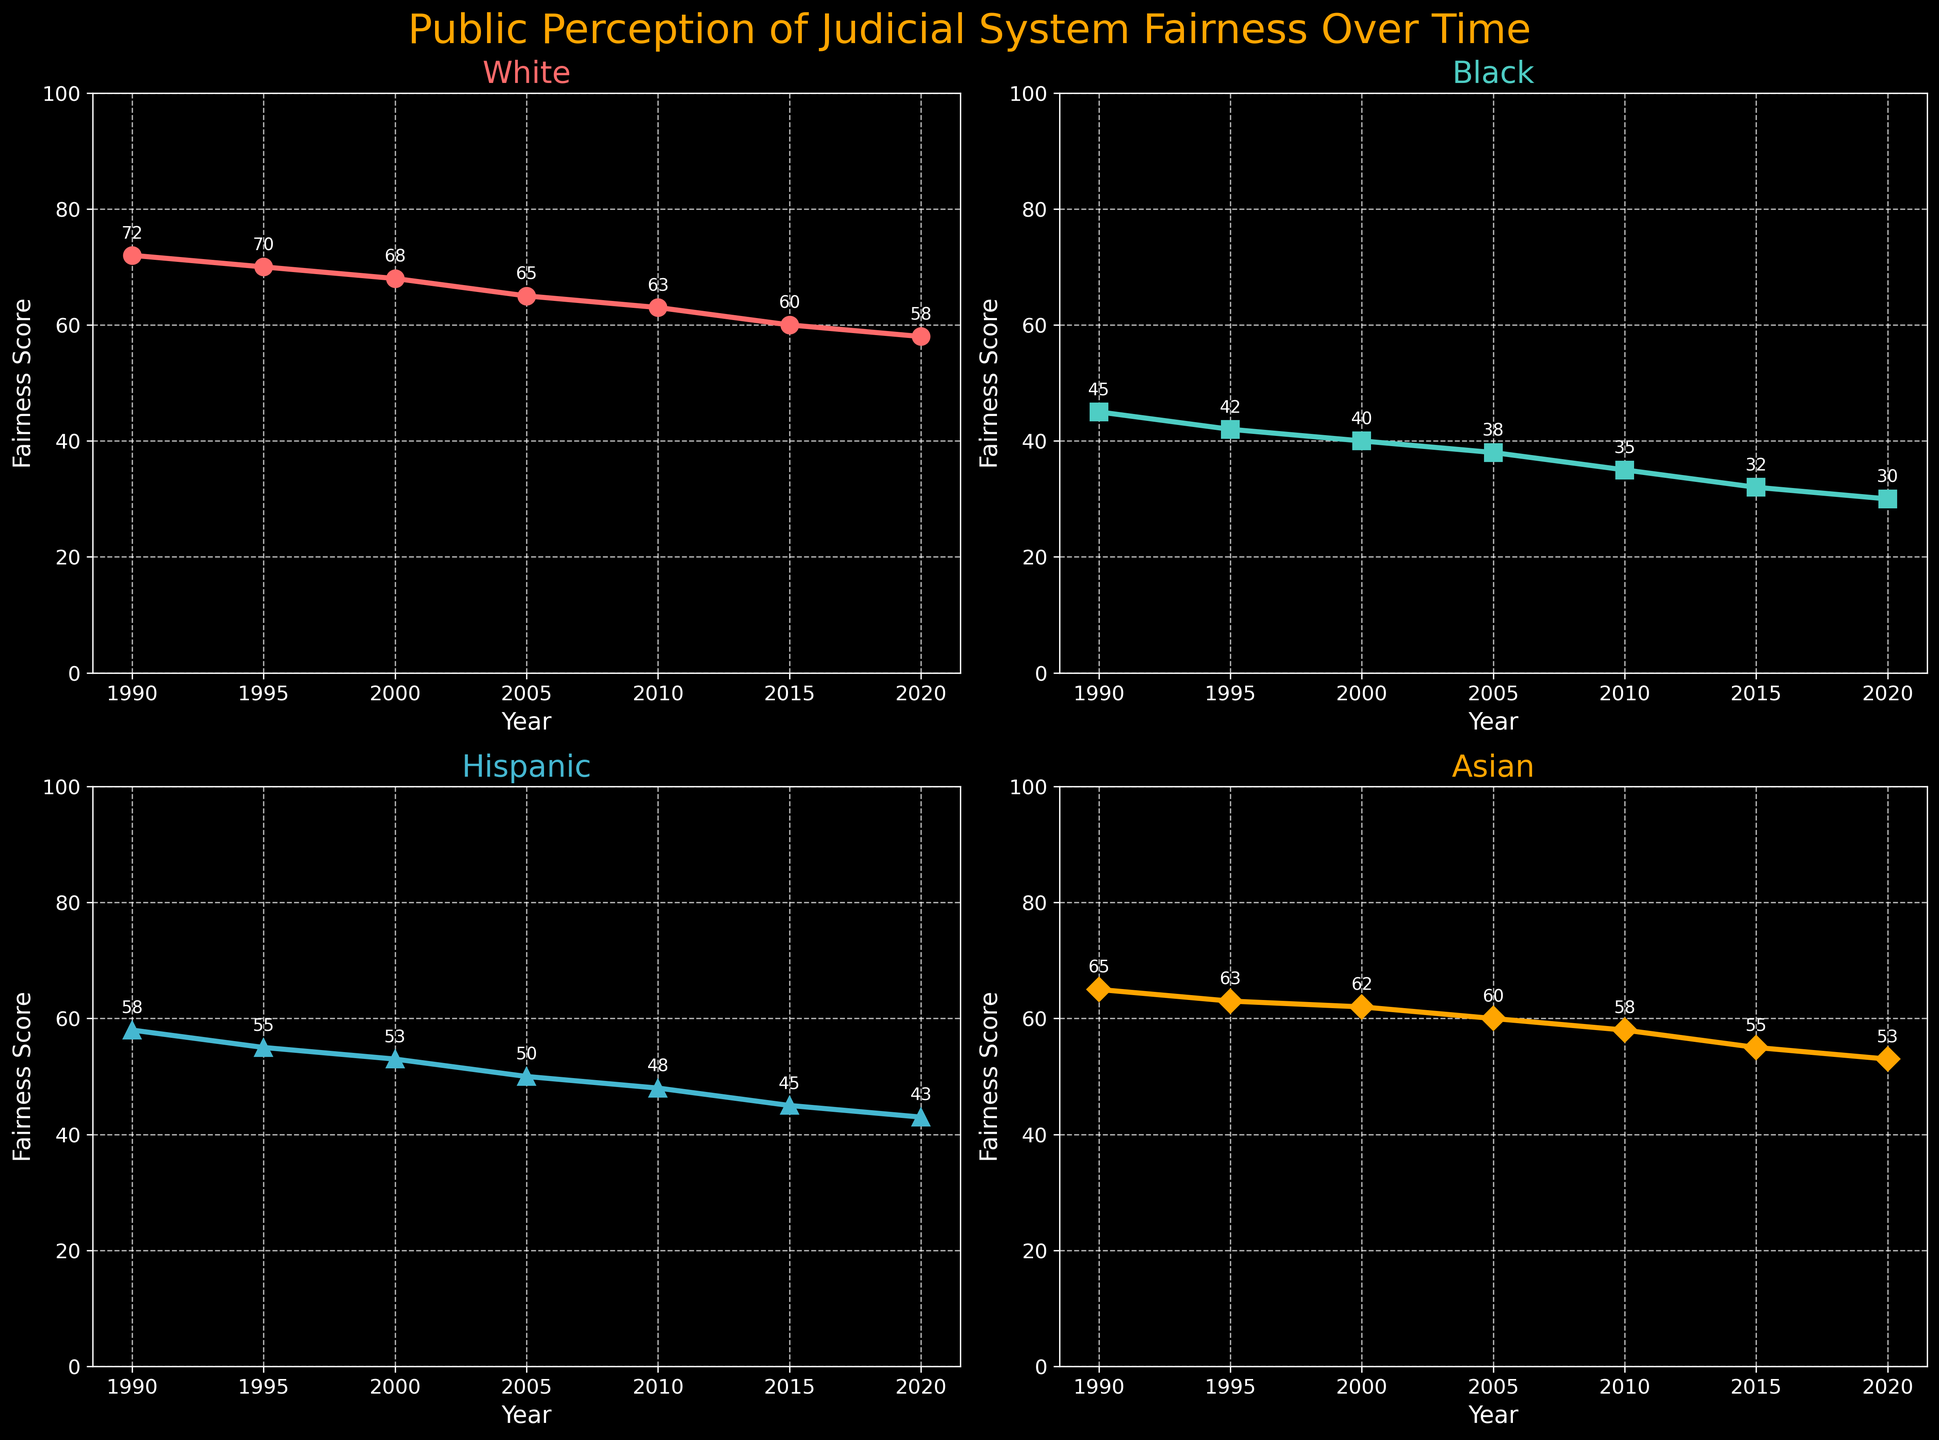What is the overall trend for the fairness score of the Black demographic from 1990 to 2020? Looking at the subplot for the Black demographic, note the values of the fairness score at each year. The values are: 45 (1990), 42 (1995), 40 (2000), 38 (2005), 35 (2010), 32 (2015), 30 (2020). As years progress from 1990 to 2020, the fairness score is decreasing.
Answer: Decreasing Which demographic has the highest fairness score in 2020? On each subplot, look at the fairness score for the year 2020. The scores are: White (58), Black (30), Hispanic (43), Asian (53). Among these, the White demographic has the highest score in 2020.
Answer: White How does the fairness score of the Asian demographic in 2005 compare to the fairness score of the Hispanic demographic in the same year? Look at the 2005 fairness scores for both Asian and Hispanic demographics. The values are: Asian (60) and Hispanic (50). The Asian fairness score is higher than the Hispanic fairness score.
Answer: Higher What is the difference in the fairness score between the White and Black demographics in 1990? Compare the fairness scores of the White (72) and Black (45) demographics in 1990. The difference can be computed as 72 - 45 = 27.
Answer: 27 What is the average fairness score of the Hispanic demographic across all recorded years? Obtain the fairness scores for the Hispanic demographic which are: 58 (1990), 55 (1995), 53 (2000), 50 (2005), 48 (2010), 45 (2015), 43 (2020). Sum these scores: 58 + 55 + 53 + 50 + 48 + 45 + 43 = 352, then divide by the number of years (7). The average is 352 / 7 ≈ 50.29.
Answer: 50.29 Which demographic shows the largest decline in fairness score from 1990 to 2020? Calculate the decline for each demographic as follows: White: 72 - 58 = 14, Black: 45 - 30 = 15, Hispanic: 58 - 43 = 15, Asian: 65 - 53 = 12. Thus, the largest decline is observed in the Hispanic and Black demographics, both with a decline of 15 points.
Answer: Hispanic, Black What visible elements make it easy to differentiate each demographic on the plots? Each demographic on the subplot is differentiated by unique colors and markers, which helps in easily identifying them. The colors and markers are as follows: White (red, circles), Black (cyan, squares), Hispanic (blue, triangles), Asian (orange, diamonds).
Answer: Colors and markers At what year did the fairness score of the Asian demographic first drop below 60? Look at the fairness score values for the Asian demographic over the years. The score first drops below 60 in 2010, where it reaches 58.
Answer: 2010 Which demographic had the smallest change in fairness score from 1990 to 2000? Assess the changes over this period: White: 72 to 68 (change: 4), Black: 45 to 40 (change: 5), Hispanic: 58 to 53 (change: 5), Asian: 65 to 62 (change: 3). The Asian demographic had the smallest change.
Answer: Asian 